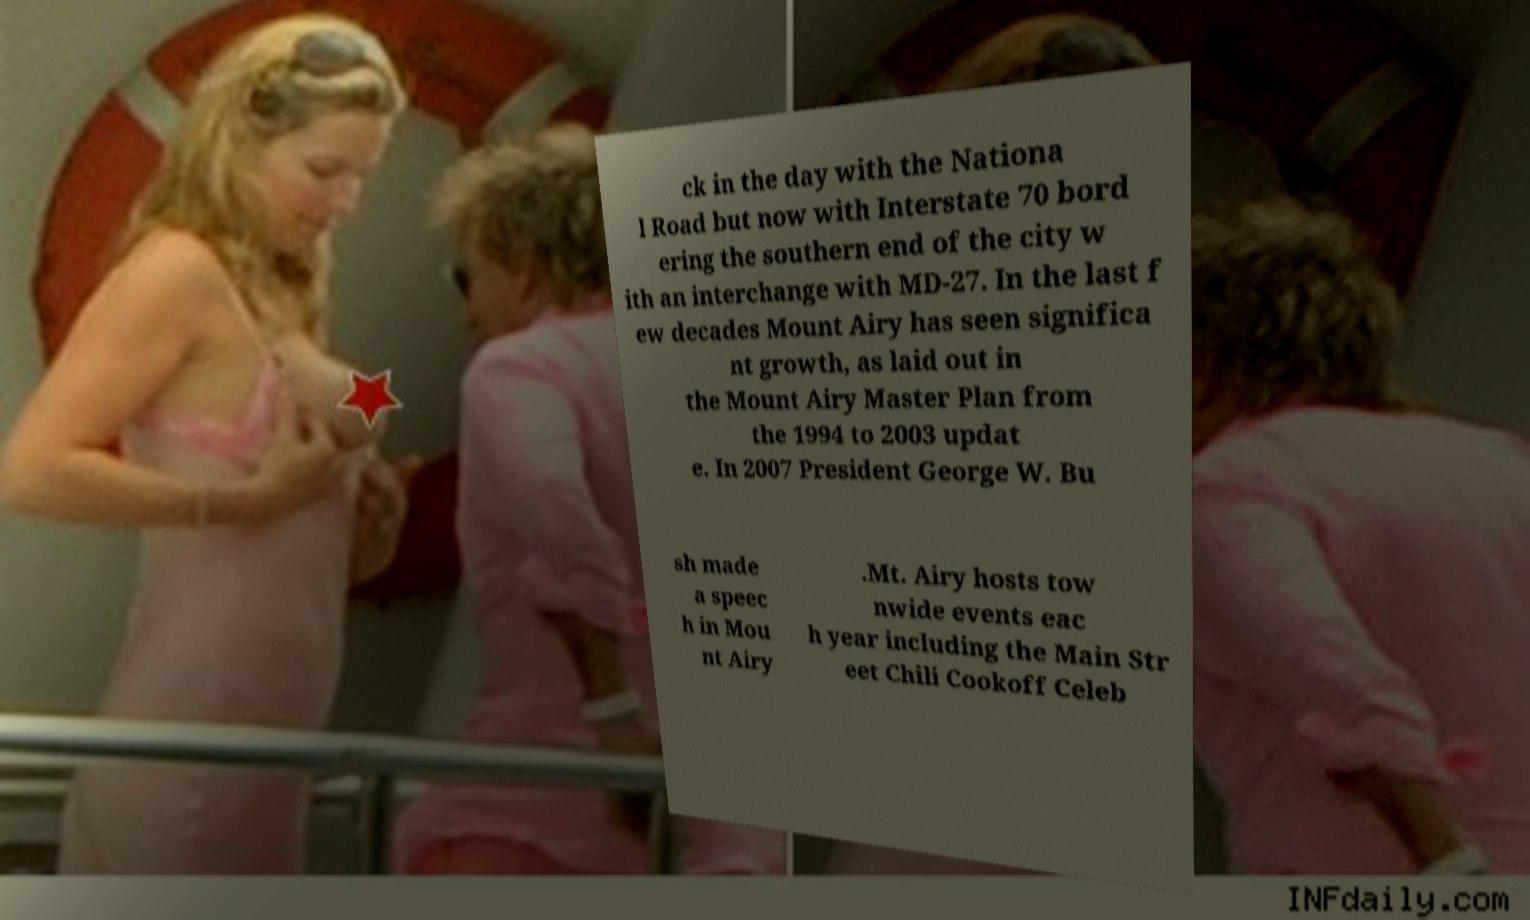Please read and relay the text visible in this image. What does it say? ck in the day with the Nationa l Road but now with Interstate 70 bord ering the southern end of the city w ith an interchange with MD-27. In the last f ew decades Mount Airy has seen significa nt growth, as laid out in the Mount Airy Master Plan from the 1994 to 2003 updat e. In 2007 President George W. Bu sh made a speec h in Mou nt Airy .Mt. Airy hosts tow nwide events eac h year including the Main Str eet Chili Cookoff Celeb 